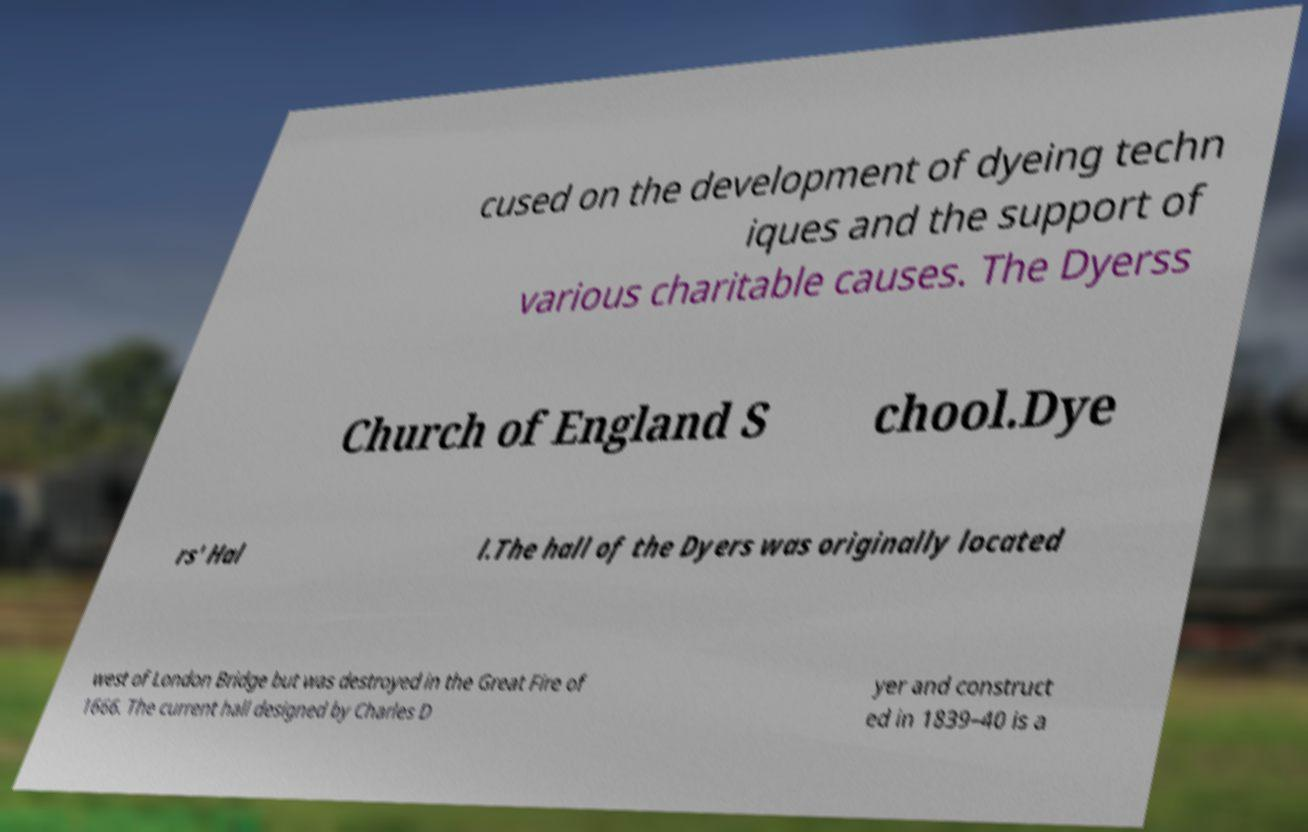Can you read and provide the text displayed in the image?This photo seems to have some interesting text. Can you extract and type it out for me? cused on the development of dyeing techn iques and the support of various charitable causes. The Dyerss Church of England S chool.Dye rs' Hal l.The hall of the Dyers was originally located west of London Bridge but was destroyed in the Great Fire of 1666. The current hall designed by Charles D yer and construct ed in 1839–40 is a 